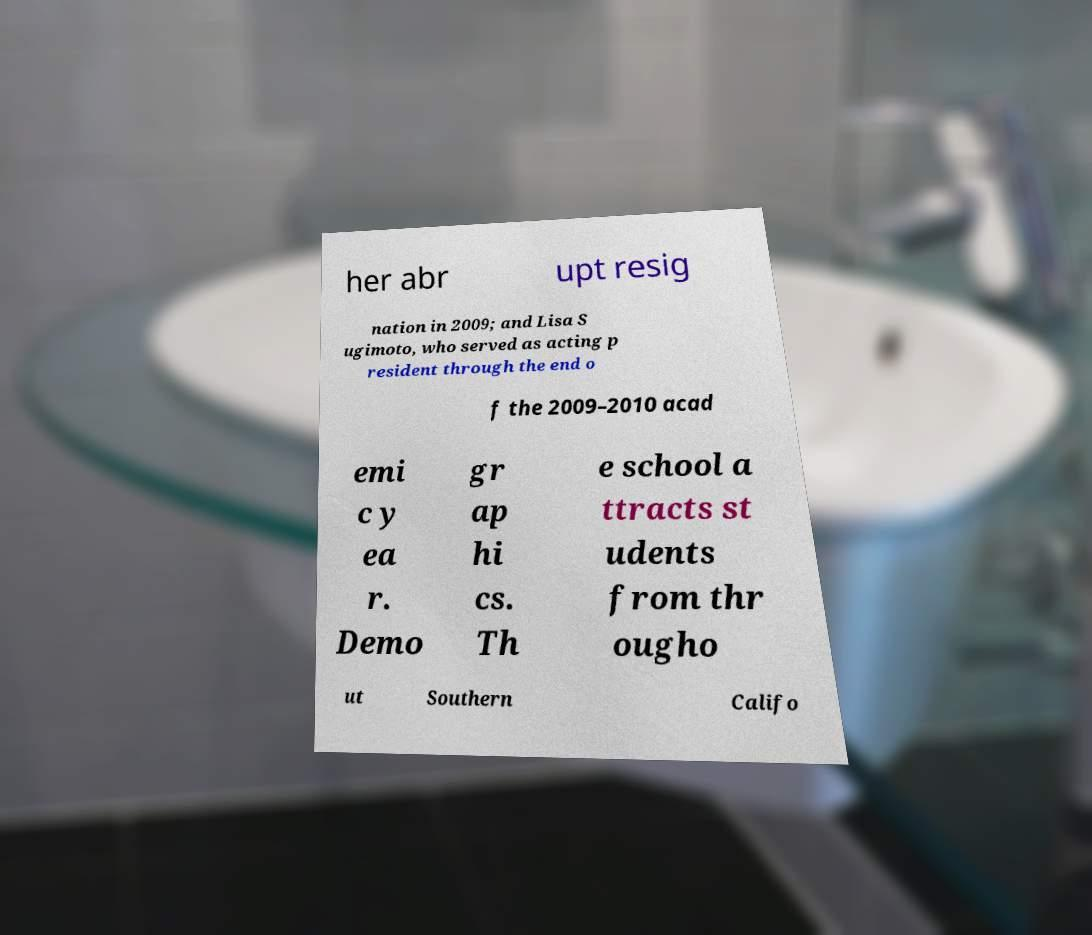For documentation purposes, I need the text within this image transcribed. Could you provide that? her abr upt resig nation in 2009; and Lisa S ugimoto, who served as acting p resident through the end o f the 2009–2010 acad emi c y ea r. Demo gr ap hi cs. Th e school a ttracts st udents from thr ougho ut Southern Califo 